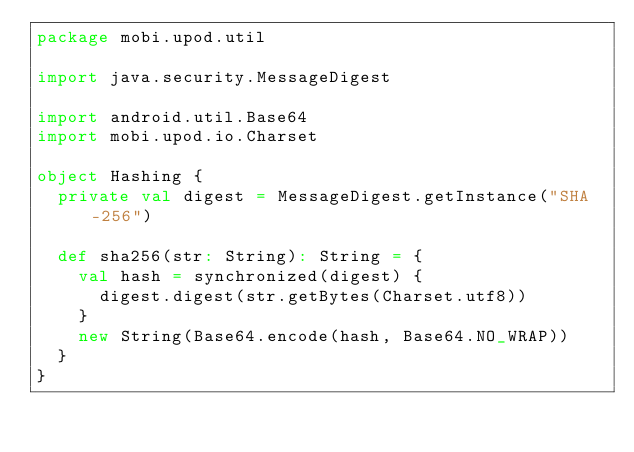Convert code to text. <code><loc_0><loc_0><loc_500><loc_500><_Scala_>package mobi.upod.util

import java.security.MessageDigest

import android.util.Base64
import mobi.upod.io.Charset

object Hashing {
  private val digest = MessageDigest.getInstance("SHA-256")

  def sha256(str: String): String = {
    val hash = synchronized(digest) {
      digest.digest(str.getBytes(Charset.utf8))
    }
    new String(Base64.encode(hash, Base64.NO_WRAP))
  }
}
</code> 